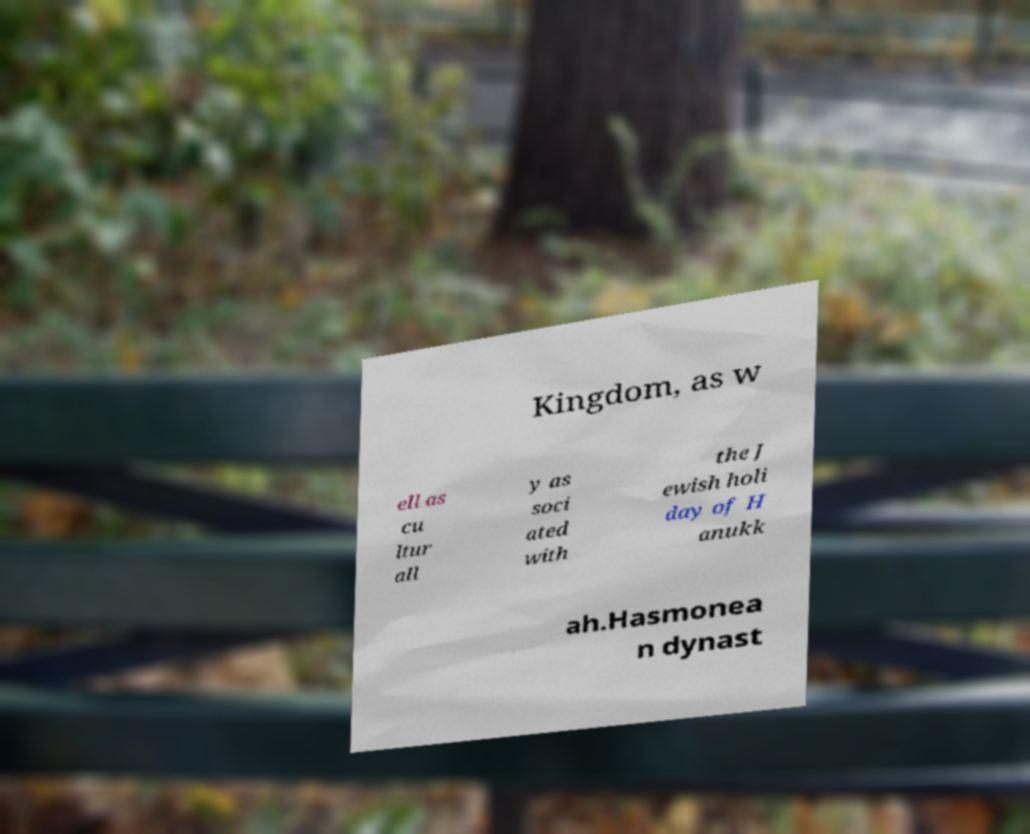What messages or text are displayed in this image? I need them in a readable, typed format. Kingdom, as w ell as cu ltur all y as soci ated with the J ewish holi day of H anukk ah.Hasmonea n dynast 